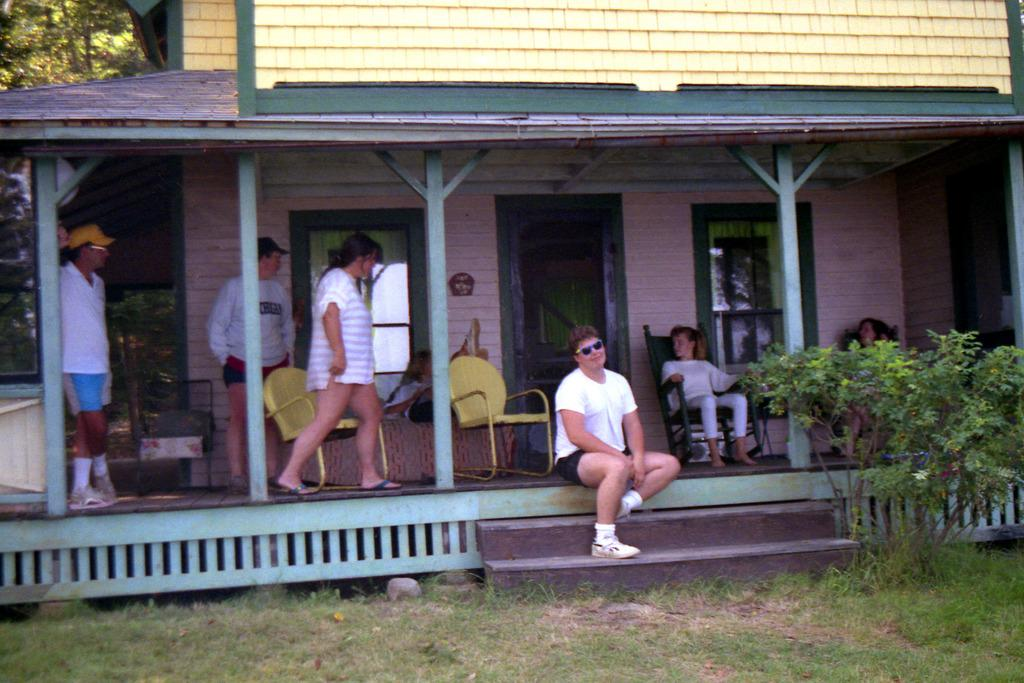What type of structure is visible in the image? There is a house in the image. What type of furniture is present in the image? There are chairs in the image. Who or what can be seen in the image? There are people in the image. What type of vegetation is visible in the image? There are plants, grass, and trees in the image. What architectural features can be seen in the house? There are windows and a door in the image. What are some people doing in the image? Some people are sitting in the image. What type of boat is visible in the image? There is no boat present in the image. What type of prison can be seen in the image? There is no prison present in the image. 